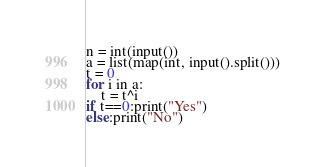<code> <loc_0><loc_0><loc_500><loc_500><_Python_>n = int(input())
a = list(map(int, input().split()))
t = 0
for i in a:
    t = t^i
if t==0:print("Yes")
else:print("No")</code> 